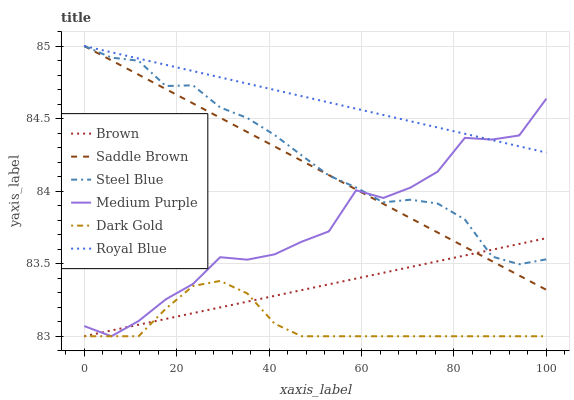Does Dark Gold have the minimum area under the curve?
Answer yes or no. Yes. Does Royal Blue have the maximum area under the curve?
Answer yes or no. Yes. Does Steel Blue have the minimum area under the curve?
Answer yes or no. No. Does Steel Blue have the maximum area under the curve?
Answer yes or no. No. Is Brown the smoothest?
Answer yes or no. Yes. Is Medium Purple the roughest?
Answer yes or no. Yes. Is Dark Gold the smoothest?
Answer yes or no. No. Is Dark Gold the roughest?
Answer yes or no. No. Does Steel Blue have the lowest value?
Answer yes or no. No. Does Saddle Brown have the highest value?
Answer yes or no. Yes. Does Dark Gold have the highest value?
Answer yes or no. No. Is Dark Gold less than Royal Blue?
Answer yes or no. Yes. Is Royal Blue greater than Brown?
Answer yes or no. Yes. Does Royal Blue intersect Saddle Brown?
Answer yes or no. Yes. Is Royal Blue less than Saddle Brown?
Answer yes or no. No. Is Royal Blue greater than Saddle Brown?
Answer yes or no. No. Does Dark Gold intersect Royal Blue?
Answer yes or no. No. 